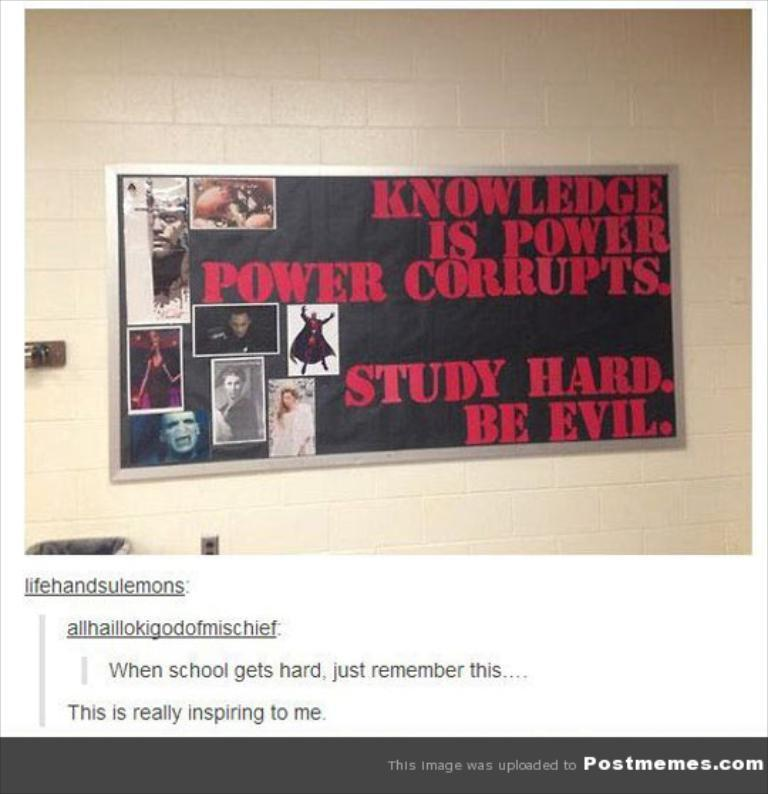What is on the wall in the image? There is a poster on the wall in the image. What can be found on the poster? The poster contains images and text. Can you describe the text on the poster? There is text written on the poster. What other text is present in the image? There is text written at the bottom of the image. What type of door is depicted in the poster? There is no door depicted in the poster; it contains images and text related to other subjects. 